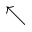<formula> <loc_0><loc_0><loc_500><loc_500>\nwarrow</formula> 